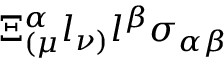<formula> <loc_0><loc_0><loc_500><loc_500>\Xi _ { ( \mu } ^ { \alpha } l _ { \nu ) } l ^ { \beta } \sigma _ { \alpha \beta }</formula> 